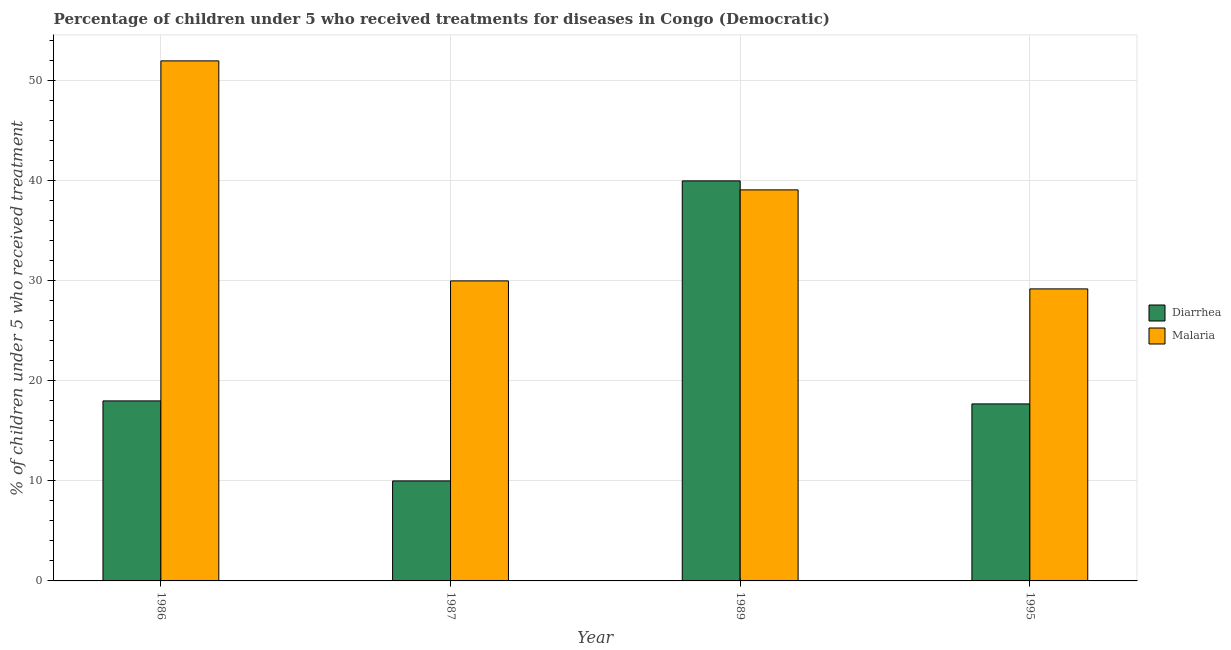Are the number of bars on each tick of the X-axis equal?
Your answer should be compact. Yes. How many bars are there on the 2nd tick from the left?
Your response must be concise. 2. What is the label of the 1st group of bars from the left?
Make the answer very short. 1986. What is the percentage of children who received treatment for malaria in 1989?
Provide a short and direct response. 39.1. Across all years, what is the maximum percentage of children who received treatment for diarrhoea?
Make the answer very short. 40. Across all years, what is the minimum percentage of children who received treatment for diarrhoea?
Your answer should be very brief. 10. What is the total percentage of children who received treatment for diarrhoea in the graph?
Offer a very short reply. 85.7. What is the difference between the percentage of children who received treatment for malaria in 1986 and that in 1989?
Your response must be concise. 12.9. What is the difference between the percentage of children who received treatment for malaria in 1986 and the percentage of children who received treatment for diarrhoea in 1989?
Your answer should be very brief. 12.9. What is the average percentage of children who received treatment for diarrhoea per year?
Offer a terse response. 21.43. In how many years, is the percentage of children who received treatment for diarrhoea greater than 12 %?
Make the answer very short. 3. What is the ratio of the percentage of children who received treatment for malaria in 1986 to that in 1989?
Your answer should be compact. 1.33. Is the percentage of children who received treatment for diarrhoea in 1986 less than that in 1995?
Your answer should be compact. No. Is the difference between the percentage of children who received treatment for diarrhoea in 1986 and 1989 greater than the difference between the percentage of children who received treatment for malaria in 1986 and 1989?
Offer a terse response. No. What is the difference between the highest and the second highest percentage of children who received treatment for diarrhoea?
Offer a very short reply. 22. What is the difference between the highest and the lowest percentage of children who received treatment for malaria?
Provide a succinct answer. 22.8. Is the sum of the percentage of children who received treatment for malaria in 1986 and 1987 greater than the maximum percentage of children who received treatment for diarrhoea across all years?
Ensure brevity in your answer.  Yes. What does the 1st bar from the left in 1995 represents?
Offer a terse response. Diarrhea. What does the 2nd bar from the right in 1987 represents?
Ensure brevity in your answer.  Diarrhea. How many bars are there?
Provide a succinct answer. 8. How many years are there in the graph?
Provide a short and direct response. 4. What is the difference between two consecutive major ticks on the Y-axis?
Ensure brevity in your answer.  10. Does the graph contain any zero values?
Give a very brief answer. No. Does the graph contain grids?
Ensure brevity in your answer.  Yes. Where does the legend appear in the graph?
Your answer should be very brief. Center right. How are the legend labels stacked?
Provide a short and direct response. Vertical. What is the title of the graph?
Ensure brevity in your answer.  Percentage of children under 5 who received treatments for diseases in Congo (Democratic). What is the label or title of the X-axis?
Your response must be concise. Year. What is the label or title of the Y-axis?
Give a very brief answer. % of children under 5 who received treatment. What is the % of children under 5 who received treatment in Diarrhea in 1987?
Make the answer very short. 10. What is the % of children under 5 who received treatment of Malaria in 1987?
Keep it short and to the point. 30. What is the % of children under 5 who received treatment of Diarrhea in 1989?
Provide a succinct answer. 40. What is the % of children under 5 who received treatment in Malaria in 1989?
Provide a short and direct response. 39.1. What is the % of children under 5 who received treatment in Diarrhea in 1995?
Your answer should be compact. 17.7. What is the % of children under 5 who received treatment in Malaria in 1995?
Provide a succinct answer. 29.2. Across all years, what is the maximum % of children under 5 who received treatment in Diarrhea?
Give a very brief answer. 40. Across all years, what is the maximum % of children under 5 who received treatment in Malaria?
Your response must be concise. 52. Across all years, what is the minimum % of children under 5 who received treatment in Malaria?
Your response must be concise. 29.2. What is the total % of children under 5 who received treatment in Diarrhea in the graph?
Provide a succinct answer. 85.7. What is the total % of children under 5 who received treatment in Malaria in the graph?
Make the answer very short. 150.3. What is the difference between the % of children under 5 who received treatment in Diarrhea in 1986 and that in 1987?
Provide a succinct answer. 8. What is the difference between the % of children under 5 who received treatment of Malaria in 1986 and that in 1987?
Give a very brief answer. 22. What is the difference between the % of children under 5 who received treatment in Diarrhea in 1986 and that in 1989?
Provide a short and direct response. -22. What is the difference between the % of children under 5 who received treatment of Malaria in 1986 and that in 1989?
Your answer should be very brief. 12.9. What is the difference between the % of children under 5 who received treatment in Malaria in 1986 and that in 1995?
Provide a short and direct response. 22.8. What is the difference between the % of children under 5 who received treatment in Diarrhea in 1987 and that in 1989?
Offer a very short reply. -30. What is the difference between the % of children under 5 who received treatment of Malaria in 1987 and that in 1989?
Offer a very short reply. -9.1. What is the difference between the % of children under 5 who received treatment of Diarrhea in 1987 and that in 1995?
Give a very brief answer. -7.7. What is the difference between the % of children under 5 who received treatment in Malaria in 1987 and that in 1995?
Provide a short and direct response. 0.8. What is the difference between the % of children under 5 who received treatment in Diarrhea in 1989 and that in 1995?
Ensure brevity in your answer.  22.3. What is the difference between the % of children under 5 who received treatment in Diarrhea in 1986 and the % of children under 5 who received treatment in Malaria in 1989?
Provide a succinct answer. -21.1. What is the difference between the % of children under 5 who received treatment in Diarrhea in 1986 and the % of children under 5 who received treatment in Malaria in 1995?
Provide a short and direct response. -11.2. What is the difference between the % of children under 5 who received treatment in Diarrhea in 1987 and the % of children under 5 who received treatment in Malaria in 1989?
Offer a terse response. -29.1. What is the difference between the % of children under 5 who received treatment in Diarrhea in 1987 and the % of children under 5 who received treatment in Malaria in 1995?
Offer a terse response. -19.2. What is the difference between the % of children under 5 who received treatment in Diarrhea in 1989 and the % of children under 5 who received treatment in Malaria in 1995?
Your response must be concise. 10.8. What is the average % of children under 5 who received treatment of Diarrhea per year?
Offer a terse response. 21.43. What is the average % of children under 5 who received treatment in Malaria per year?
Your response must be concise. 37.58. In the year 1986, what is the difference between the % of children under 5 who received treatment in Diarrhea and % of children under 5 who received treatment in Malaria?
Your answer should be very brief. -34. In the year 1995, what is the difference between the % of children under 5 who received treatment of Diarrhea and % of children under 5 who received treatment of Malaria?
Offer a terse response. -11.5. What is the ratio of the % of children under 5 who received treatment of Malaria in 1986 to that in 1987?
Give a very brief answer. 1.73. What is the ratio of the % of children under 5 who received treatment of Diarrhea in 1986 to that in 1989?
Your answer should be compact. 0.45. What is the ratio of the % of children under 5 who received treatment of Malaria in 1986 to that in 1989?
Your answer should be compact. 1.33. What is the ratio of the % of children under 5 who received treatment in Diarrhea in 1986 to that in 1995?
Provide a succinct answer. 1.02. What is the ratio of the % of children under 5 who received treatment of Malaria in 1986 to that in 1995?
Ensure brevity in your answer.  1.78. What is the ratio of the % of children under 5 who received treatment of Diarrhea in 1987 to that in 1989?
Your response must be concise. 0.25. What is the ratio of the % of children under 5 who received treatment in Malaria in 1987 to that in 1989?
Offer a terse response. 0.77. What is the ratio of the % of children under 5 who received treatment in Diarrhea in 1987 to that in 1995?
Ensure brevity in your answer.  0.56. What is the ratio of the % of children under 5 who received treatment of Malaria in 1987 to that in 1995?
Your answer should be very brief. 1.03. What is the ratio of the % of children under 5 who received treatment in Diarrhea in 1989 to that in 1995?
Your answer should be compact. 2.26. What is the ratio of the % of children under 5 who received treatment of Malaria in 1989 to that in 1995?
Offer a terse response. 1.34. What is the difference between the highest and the second highest % of children under 5 who received treatment in Malaria?
Your response must be concise. 12.9. What is the difference between the highest and the lowest % of children under 5 who received treatment of Diarrhea?
Ensure brevity in your answer.  30. What is the difference between the highest and the lowest % of children under 5 who received treatment of Malaria?
Your response must be concise. 22.8. 